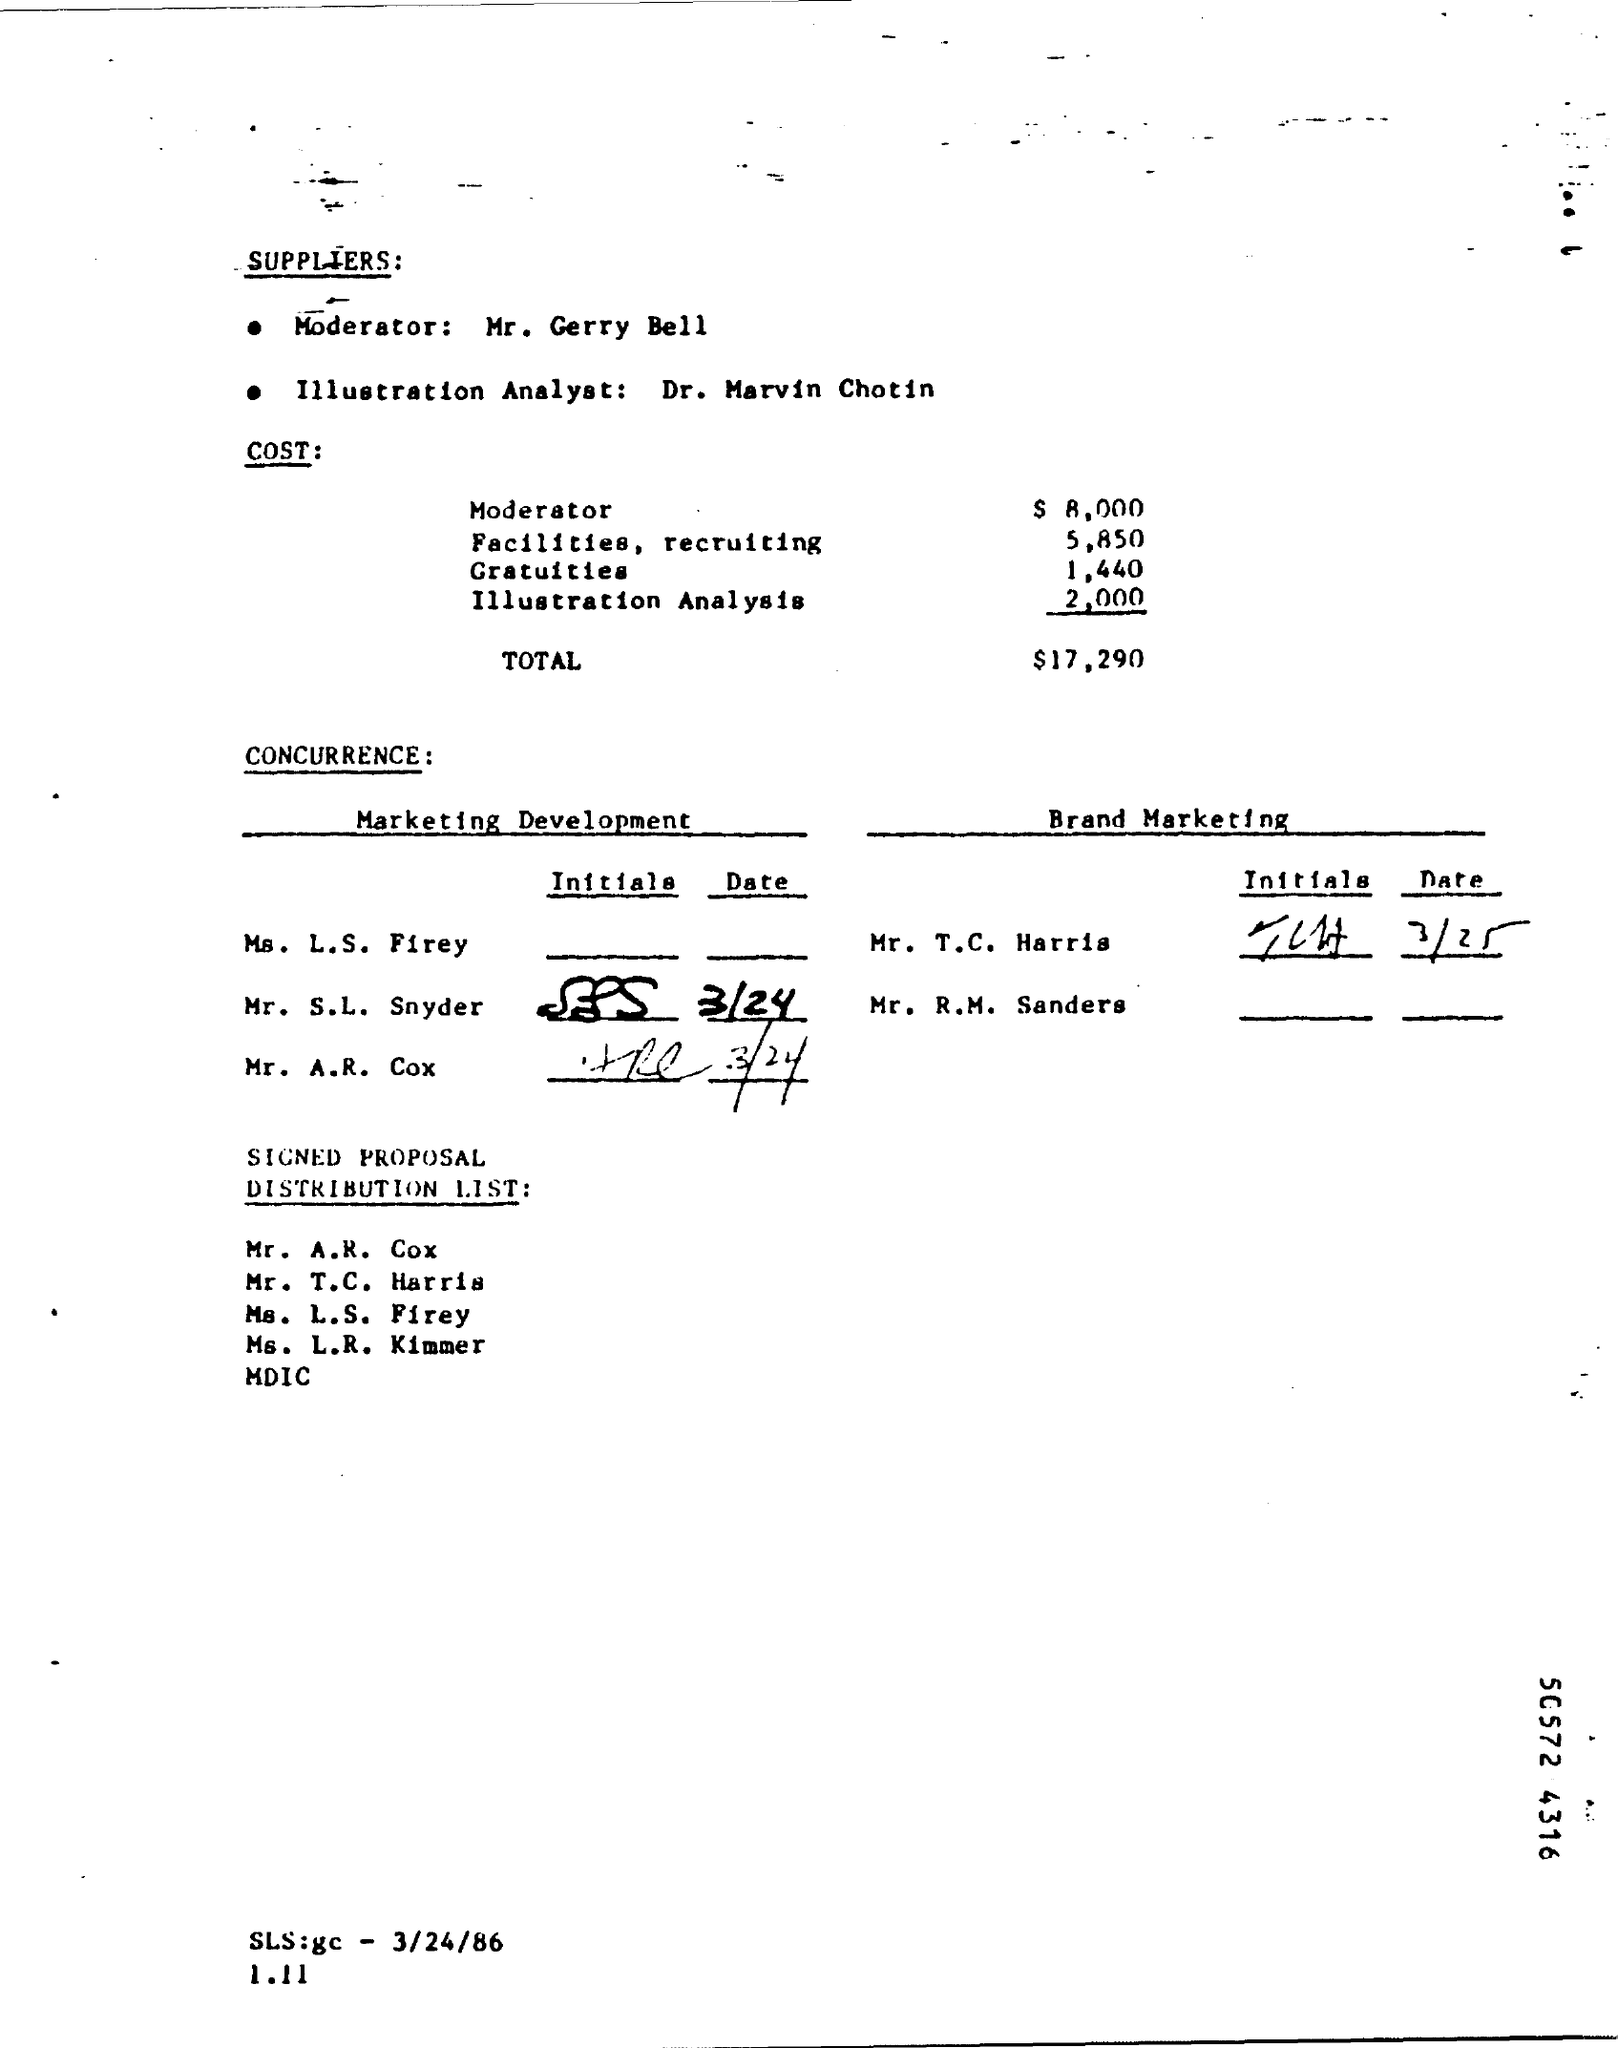What is the cost of moderator as mentioned in the given page ?
Provide a succinct answer. $ 8,000. What is the amount of gratuities mentioned in the given page ?
Offer a terse response. 1,440. What is the cost of illustration analysis ?
Give a very brief answer. $2,000. What is the total cost as mentioned in the given page ?
Offer a terse response. $17,290. 